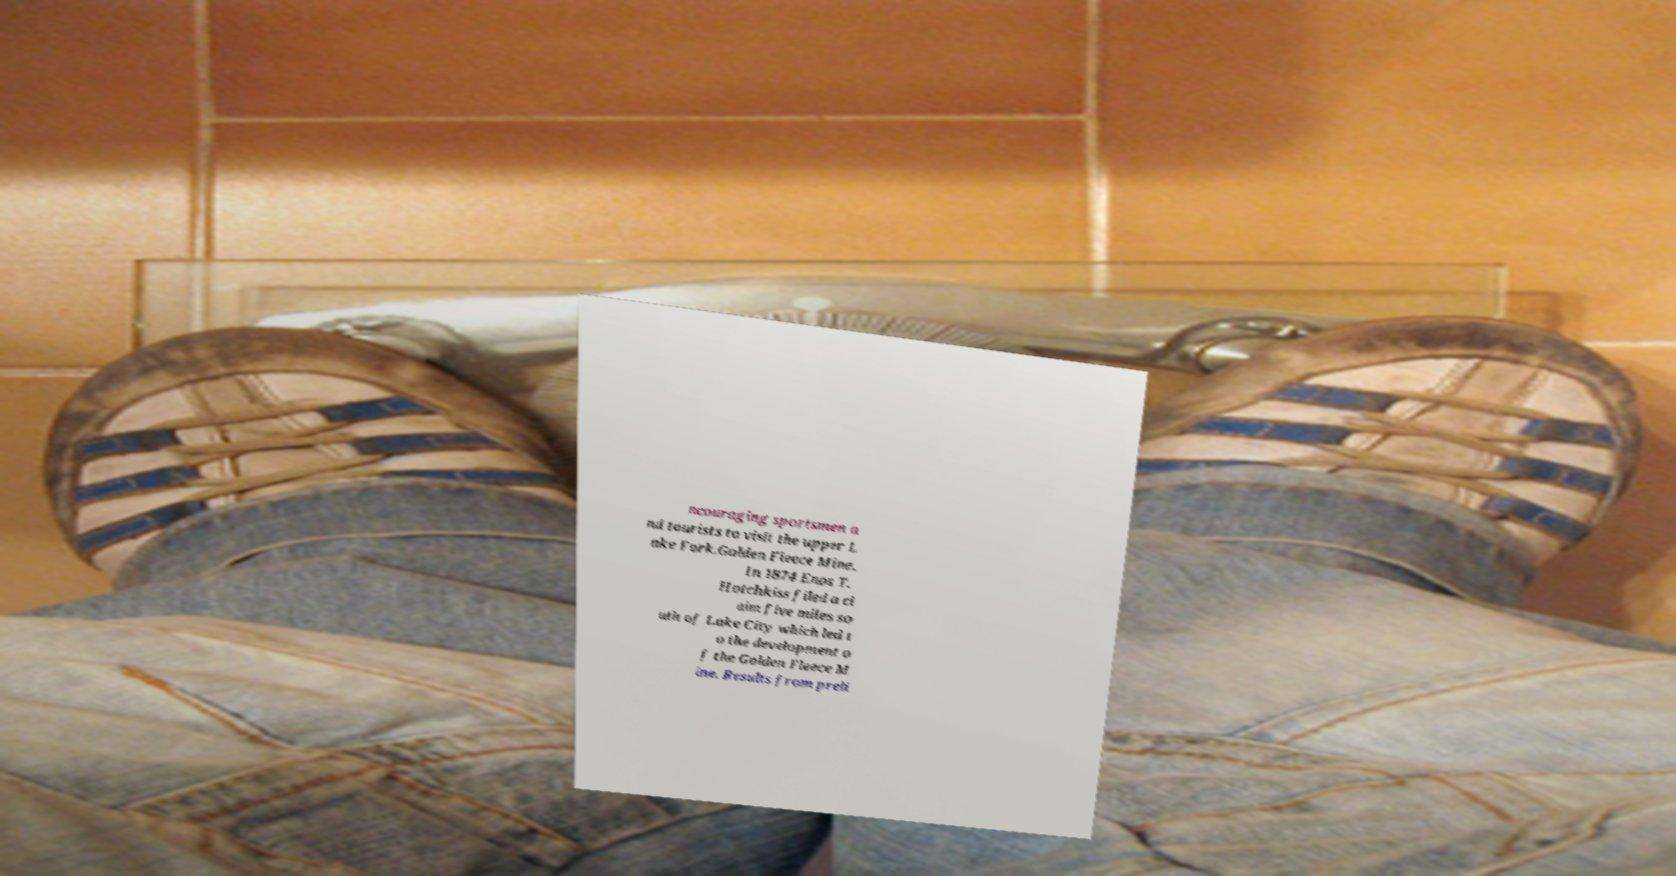Please read and relay the text visible in this image. What does it say? ncouraging sportsmen a nd tourists to visit the upper L ake Fork.Golden Fleece Mine. In 1874 Enos T. Hotchkiss filed a cl aim five miles so uth of Lake City which led t o the development o f the Golden Fleece M ine. Results from preli 